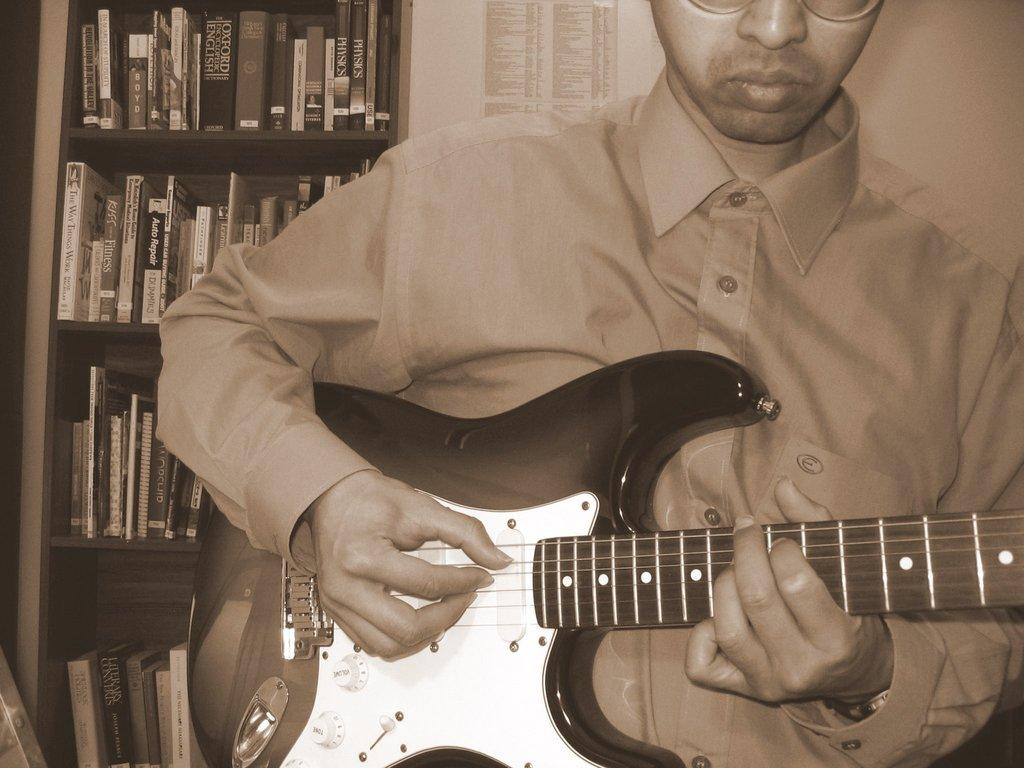Who is present in the image? There is a person in the image. What is the person holding? The person is holding a guitar. What can be seen in the background of the image? There are books in a rack and a paper on the wall in the background of the image. What type of bread is being used to adjust the guitar strings in the image? There is no bread present in the image, and the guitar strings are not being adjusted. 